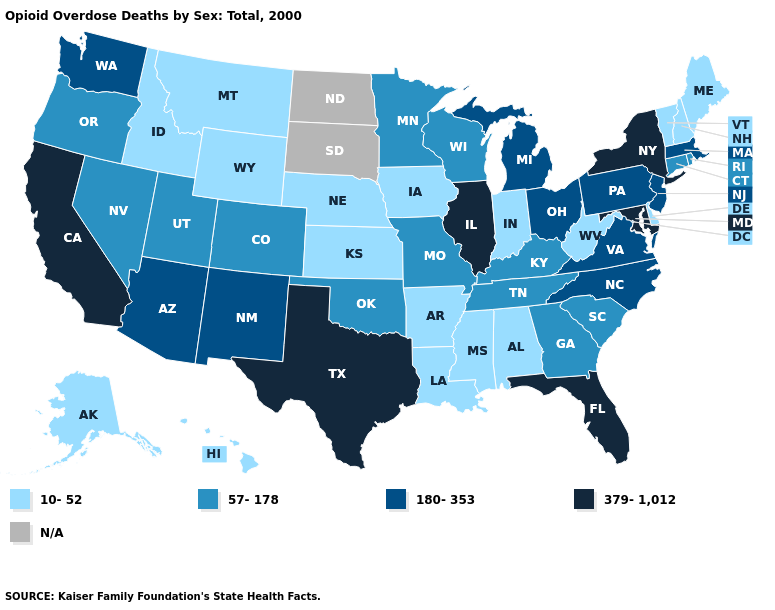Name the states that have a value in the range N/A?
Be succinct. North Dakota, South Dakota. Name the states that have a value in the range 57-178?
Give a very brief answer. Colorado, Connecticut, Georgia, Kentucky, Minnesota, Missouri, Nevada, Oklahoma, Oregon, Rhode Island, South Carolina, Tennessee, Utah, Wisconsin. What is the highest value in the West ?
Write a very short answer. 379-1,012. What is the lowest value in the West?
Write a very short answer. 10-52. What is the highest value in states that border Wyoming?
Write a very short answer. 57-178. Among the states that border Missouri , which have the lowest value?
Write a very short answer. Arkansas, Iowa, Kansas, Nebraska. What is the value of Maryland?
Concise answer only. 379-1,012. Name the states that have a value in the range N/A?
Answer briefly. North Dakota, South Dakota. How many symbols are there in the legend?
Concise answer only. 5. What is the lowest value in the West?
Keep it brief. 10-52. Does Florida have the highest value in the USA?
Quick response, please. Yes. What is the value of North Dakota?
Keep it brief. N/A. What is the value of Texas?
Concise answer only. 379-1,012. Which states have the lowest value in the South?
Give a very brief answer. Alabama, Arkansas, Delaware, Louisiana, Mississippi, West Virginia. Name the states that have a value in the range 379-1,012?
Give a very brief answer. California, Florida, Illinois, Maryland, New York, Texas. 